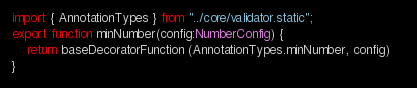Convert code to text. <code><loc_0><loc_0><loc_500><loc_500><_TypeScript_>import { AnnotationTypes } from "../core/validator.static";
export function minNumber(config:NumberConfig) {
    return baseDecoratorFunction (AnnotationTypes.minNumber, config)    
}
</code> 